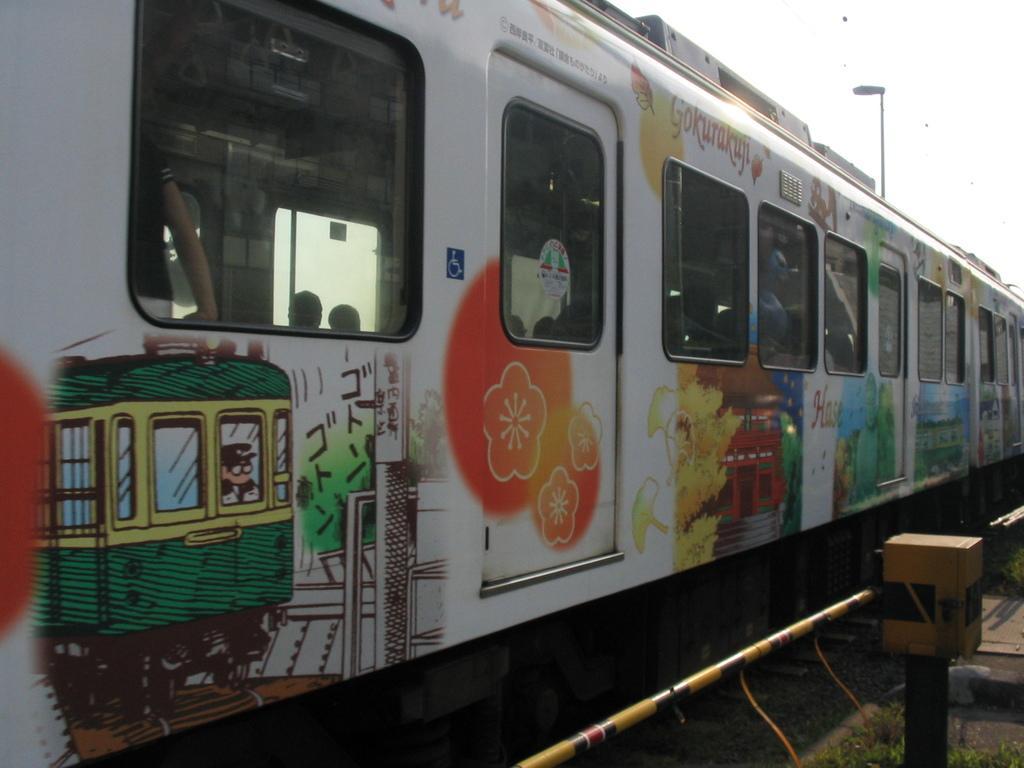Describe this image in one or two sentences. In the center of the image, we can see a train and inside the train, there are some people. In the background, there are poles, lights and we can see a rod. 